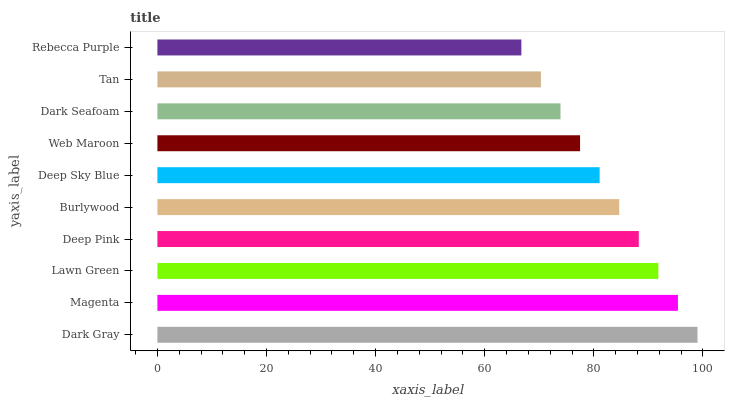Is Rebecca Purple the minimum?
Answer yes or no. Yes. Is Dark Gray the maximum?
Answer yes or no. Yes. Is Magenta the minimum?
Answer yes or no. No. Is Magenta the maximum?
Answer yes or no. No. Is Dark Gray greater than Magenta?
Answer yes or no. Yes. Is Magenta less than Dark Gray?
Answer yes or no. Yes. Is Magenta greater than Dark Gray?
Answer yes or no. No. Is Dark Gray less than Magenta?
Answer yes or no. No. Is Burlywood the high median?
Answer yes or no. Yes. Is Deep Sky Blue the low median?
Answer yes or no. Yes. Is Web Maroon the high median?
Answer yes or no. No. Is Rebecca Purple the low median?
Answer yes or no. No. 